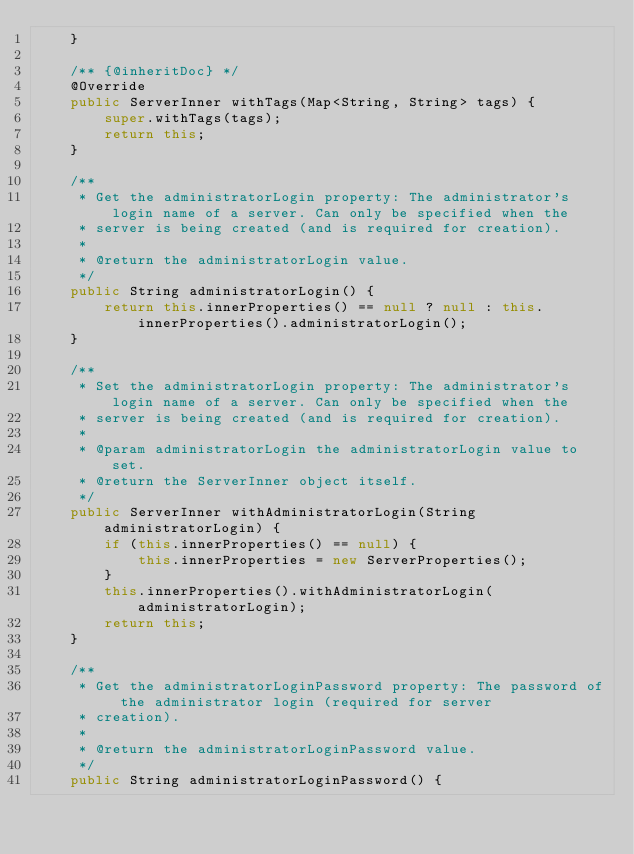<code> <loc_0><loc_0><loc_500><loc_500><_Java_>    }

    /** {@inheritDoc} */
    @Override
    public ServerInner withTags(Map<String, String> tags) {
        super.withTags(tags);
        return this;
    }

    /**
     * Get the administratorLogin property: The administrator's login name of a server. Can only be specified when the
     * server is being created (and is required for creation).
     *
     * @return the administratorLogin value.
     */
    public String administratorLogin() {
        return this.innerProperties() == null ? null : this.innerProperties().administratorLogin();
    }

    /**
     * Set the administratorLogin property: The administrator's login name of a server. Can only be specified when the
     * server is being created (and is required for creation).
     *
     * @param administratorLogin the administratorLogin value to set.
     * @return the ServerInner object itself.
     */
    public ServerInner withAdministratorLogin(String administratorLogin) {
        if (this.innerProperties() == null) {
            this.innerProperties = new ServerProperties();
        }
        this.innerProperties().withAdministratorLogin(administratorLogin);
        return this;
    }

    /**
     * Get the administratorLoginPassword property: The password of the administrator login (required for server
     * creation).
     *
     * @return the administratorLoginPassword value.
     */
    public String administratorLoginPassword() {</code> 